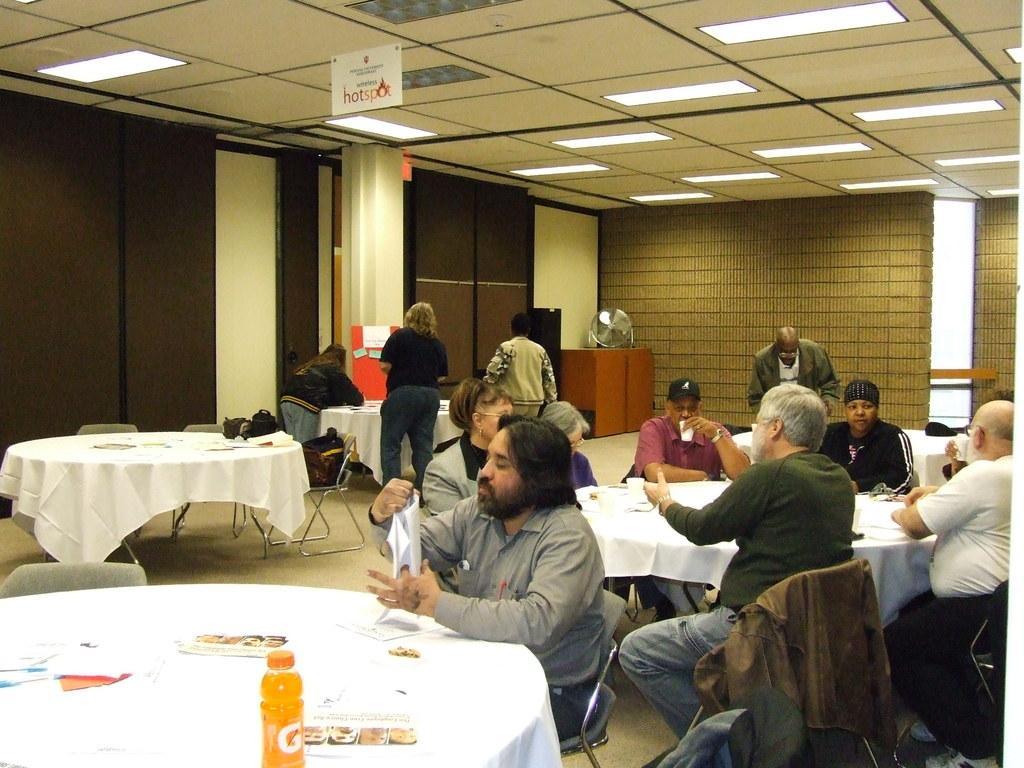Could you give a brief overview of what you see in this image? this image consists of tables and chairs. Many people are seated on the chairs. The table at the front consists of a bottle which has a orange drink. The person at the front is seated and wearing a grey shirt and holding a paper in his hand. The person behind them is standing , is wearing black t shirt and jeans. 